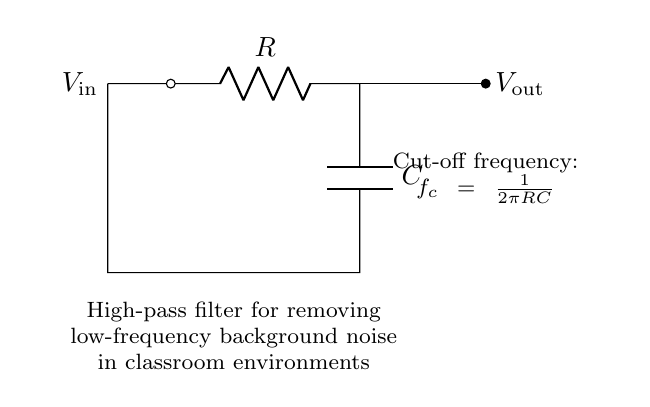What type of filter is represented in this circuit? This circuit is specifically designed as a high-pass filter, which allows high-frequency signals to pass while attenuating low-frequency signals. The presence of a resistor and capacitor arranged in this way confirms its function as a high-pass filter.
Answer: high-pass filter What components are used in the circuit? The circuit consists of a resistor (R) and a capacitor (C) connected in series. The two elements are essential for creating a high-pass filter, where the capacitor blocks low-frequency voltages and allows high-frequency signals to pass through.
Answer: resistor and capacitor What is the cut-off frequency formula for this filter? The formula for the cut-off frequency in this high-pass filter circuit is given as \(f_c = \frac{1}{2\pi RC}\). This represents the frequency at which the output voltage is reduced to 70.7% of the input voltage, indicating the transition point between passing and attenuating frequencies.
Answer: f_c = 1/(2πRC) How does this circuit affect low-frequency noise? The high-pass filter configuration diminishes low-frequency signals, effectively reducing background noise in the classroom environment. Since the filter blocks low frequencies, any unwanted low-frequency noise will be less prominent in the output signal.
Answer: it reduces low-frequency noise What would happen if the values of R or C were increased? Increasing either R or C will lower the cut-off frequency \(f_c\), causing the filter to allow even lower frequencies to pass through. This means that as R or C increases, the circuit will start to allow more of the low-frequency signals, which could result in less effective noise filtering.
Answer: the cut-off frequency decreases What is the relationship between R, C, and the cut-off frequency? The relationship is inversely proportional, as seen in the formula \(f_c = \frac{1}{2\pi RC}\). This indicates that increasing the product of R and C results in a lower cut-off frequency, allowing less high-frequency signals to pass and increasing low-frequency noise in the output.
Answer: inversely proportional 